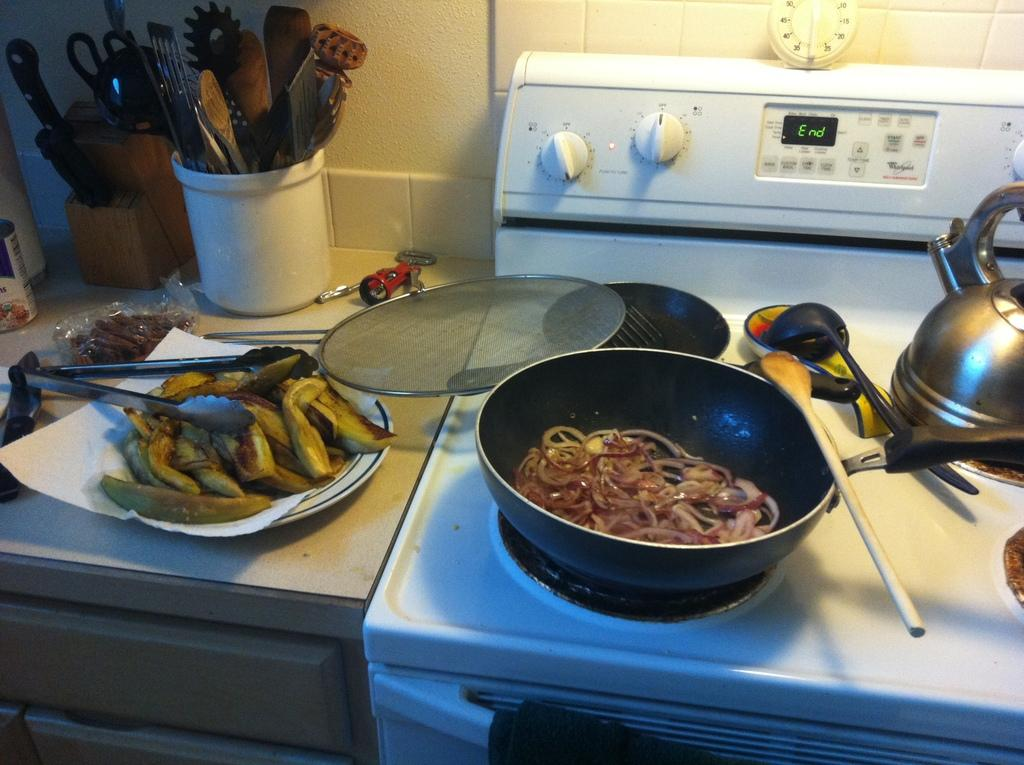<image>
Offer a succinct explanation of the picture presented. a Whirlpool stove with cooked food in pans 